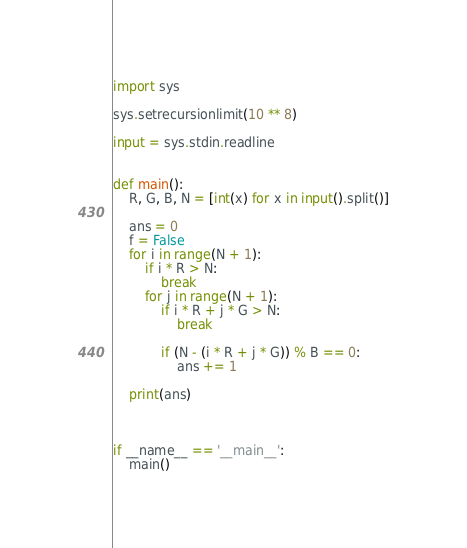Convert code to text. <code><loc_0><loc_0><loc_500><loc_500><_Python_>import sys

sys.setrecursionlimit(10 ** 8)

input = sys.stdin.readline


def main():
    R, G, B, N = [int(x) for x in input().split()]

    ans = 0
    f = False
    for i in range(N + 1):
        if i * R > N:
            break
        for j in range(N + 1):
            if i * R + j * G > N:
                break

            if (N - (i * R + j * G)) % B == 0:
                ans += 1

    print(ans)



if __name__ == '__main__':
    main()

</code> 